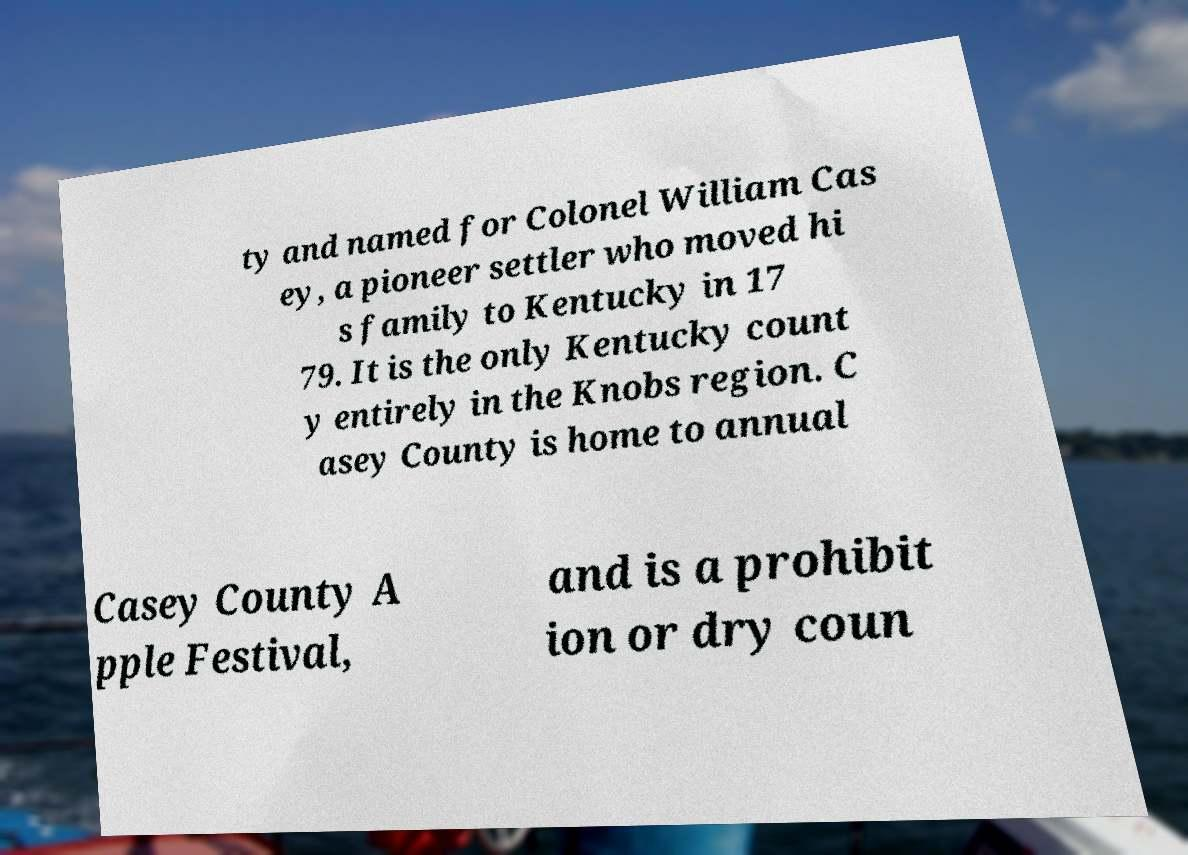Can you accurately transcribe the text from the provided image for me? ty and named for Colonel William Cas ey, a pioneer settler who moved hi s family to Kentucky in 17 79. It is the only Kentucky count y entirely in the Knobs region. C asey County is home to annual Casey County A pple Festival, and is a prohibit ion or dry coun 